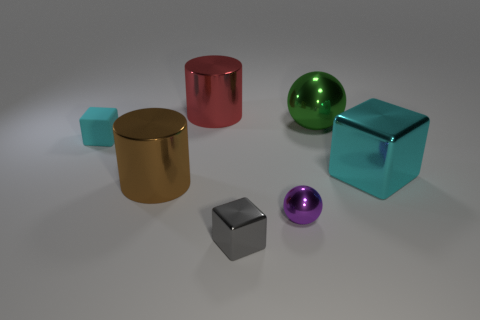Subtract all cyan blocks. How many were subtracted if there are1cyan blocks left? 1 Subtract all small cyan cubes. How many cubes are left? 2 Add 1 tiny gray metal cubes. How many objects exist? 8 Subtract all gray cylinders. How many cyan cubes are left? 2 Subtract all blocks. How many objects are left? 4 Subtract 0 gray spheres. How many objects are left? 7 Subtract 1 spheres. How many spheres are left? 1 Subtract all cyan cubes. Subtract all yellow cylinders. How many cubes are left? 1 Subtract all tiny cyan things. Subtract all large green rubber blocks. How many objects are left? 6 Add 1 small spheres. How many small spheres are left? 2 